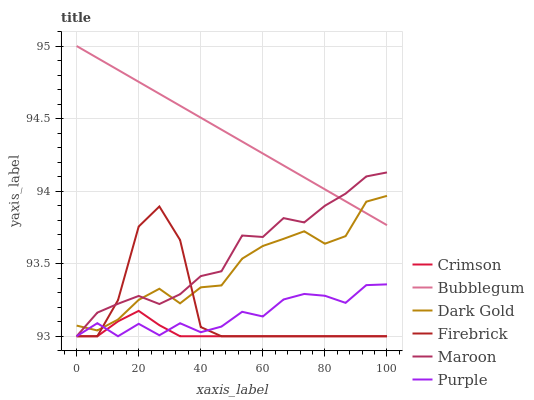Does Crimson have the minimum area under the curve?
Answer yes or no. Yes. Does Bubblegum have the maximum area under the curve?
Answer yes or no. Yes. Does Purple have the minimum area under the curve?
Answer yes or no. No. Does Purple have the maximum area under the curve?
Answer yes or no. No. Is Bubblegum the smoothest?
Answer yes or no. Yes. Is Firebrick the roughest?
Answer yes or no. Yes. Is Purple the smoothest?
Answer yes or no. No. Is Purple the roughest?
Answer yes or no. No. Does Purple have the lowest value?
Answer yes or no. Yes. Does Bubblegum have the lowest value?
Answer yes or no. No. Does Bubblegum have the highest value?
Answer yes or no. Yes. Does Purple have the highest value?
Answer yes or no. No. Is Crimson less than Dark Gold?
Answer yes or no. Yes. Is Dark Gold greater than Crimson?
Answer yes or no. Yes. Does Crimson intersect Maroon?
Answer yes or no. Yes. Is Crimson less than Maroon?
Answer yes or no. No. Is Crimson greater than Maroon?
Answer yes or no. No. Does Crimson intersect Dark Gold?
Answer yes or no. No. 